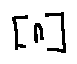<formula> <loc_0><loc_0><loc_500><loc_500>[ n ]</formula> 